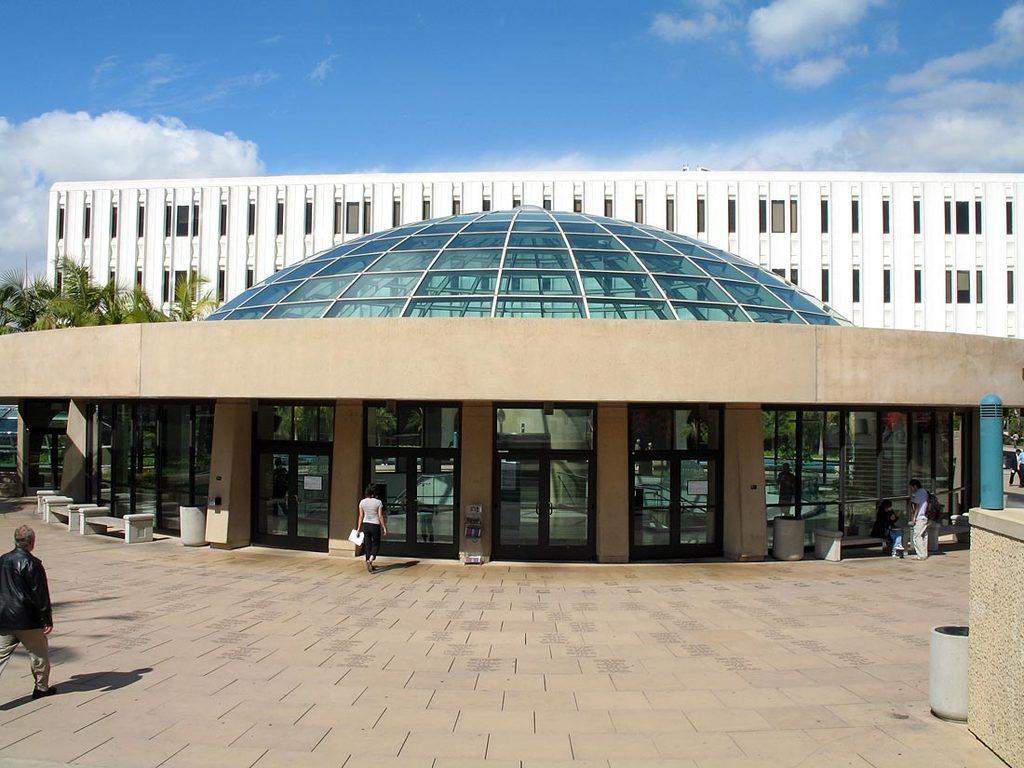How would you summarize this image in a sentence or two? In this image there is a building in the middle. At the bottom there are glass doors. There is a woman who is entering into the building. At the top there is the sky. On the left side there are trees in between the buildings. On the right side there is a blue color pole. 